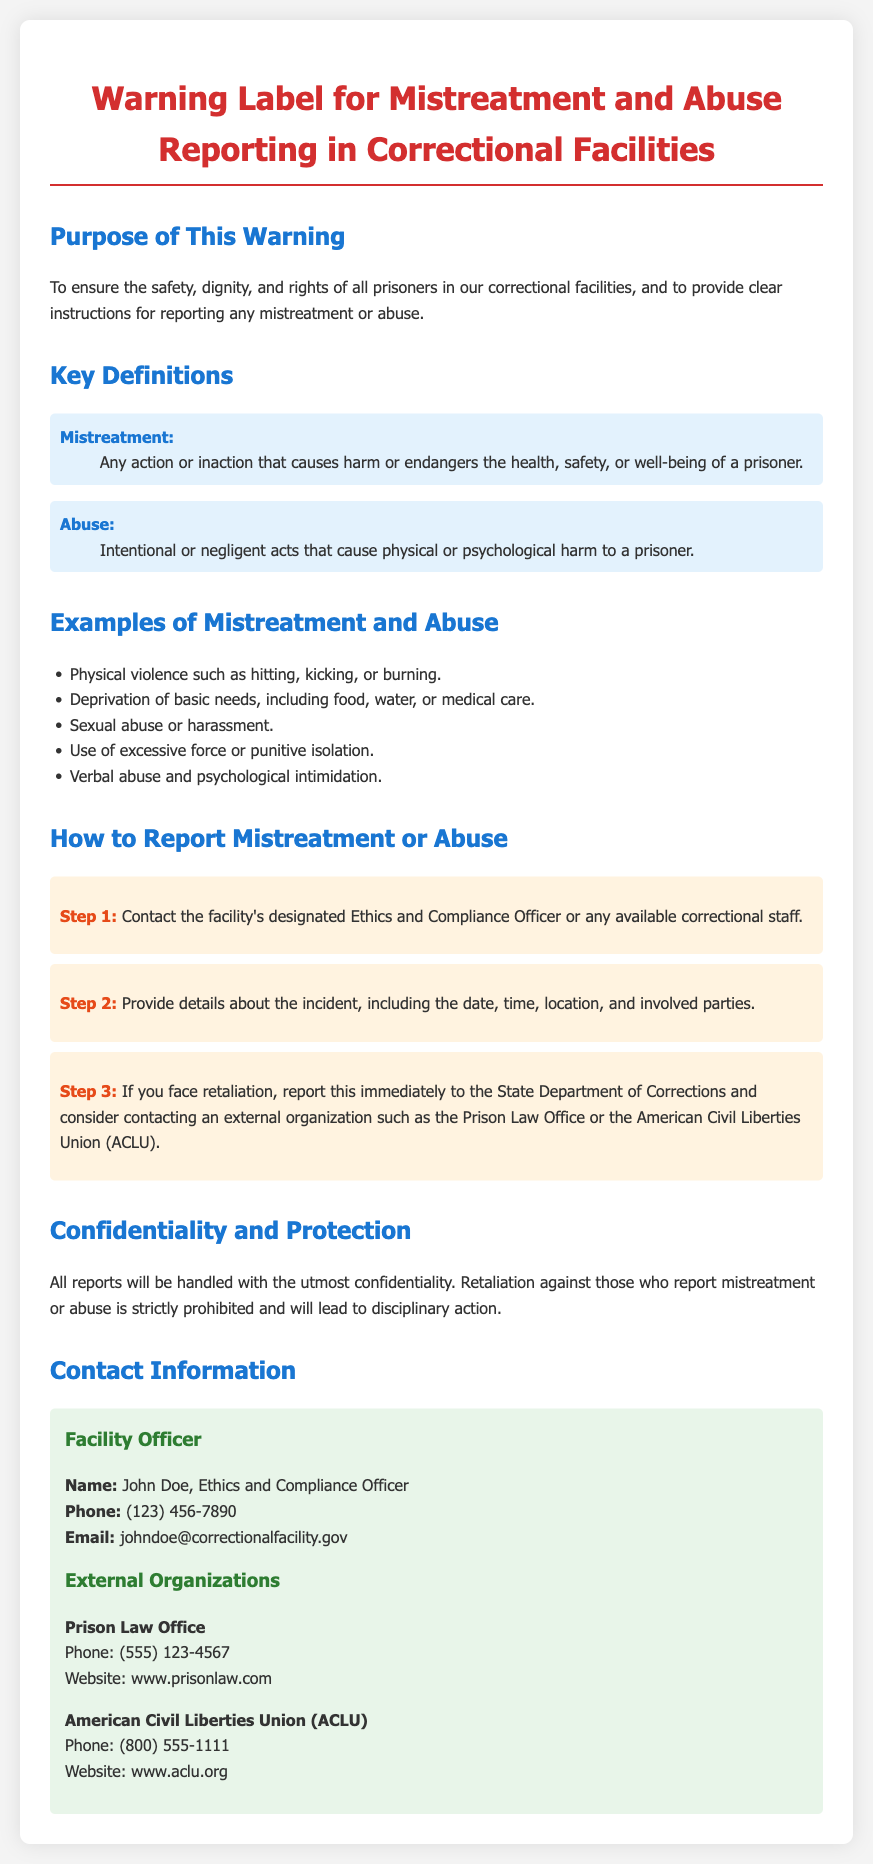What is the purpose of this warning label? The purpose of the warning label is to ensure the safety, dignity, and rights of all prisoners, and to provide clear instructions for reporting mistreatment or abuse.
Answer: To ensure the safety, dignity, and rights of all prisoners What defines mistreatment? Mistreatment is defined in the document as any action or inaction that causes harm or endangers the health, safety, or well-being of a prisoner.
Answer: Any action or inaction that causes harm or endangers the health, safety, or well-being of a prisoner How many steps are there to report mistreatment or abuse? The document outlines a specific number of steps to report mistreatment or abuse, which are detailed in the reporting section.
Answer: Three steps What is the first step in reporting mistreatment? The first step involves contacting the facility's designated Ethics and Compliance Officer or any available correctional staff.
Answer: Contact the facility's designated Ethics and Compliance Officer or any available correctional staff Who is the Ethics and Compliance Officer mentioned? The document names John Doe as the Ethics and Compliance Officer responsible for handling reports of mistreatment.
Answer: John Doe What is prohibited against those who report mistreatment? The document explicitly states that retaliation against those who report mistreatment or abuse is strictly prohibited.
Answer: Retaliation Which organization can be contacted for external support? The document lists specific external organizations that can be contacted for additional support in case of mistreatment reports.
Answer: American Civil Liberties Union (ACLU) What type of harm does abuse refer to? Abuse is defined in the document as acts that cause physical or psychological harm to a prisoner.
Answer: Physical or psychological harm 